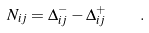Convert formula to latex. <formula><loc_0><loc_0><loc_500><loc_500>N _ { i j } = \Delta _ { i j } ^ { - } - \Delta _ { i j } ^ { + } \quad .</formula> 